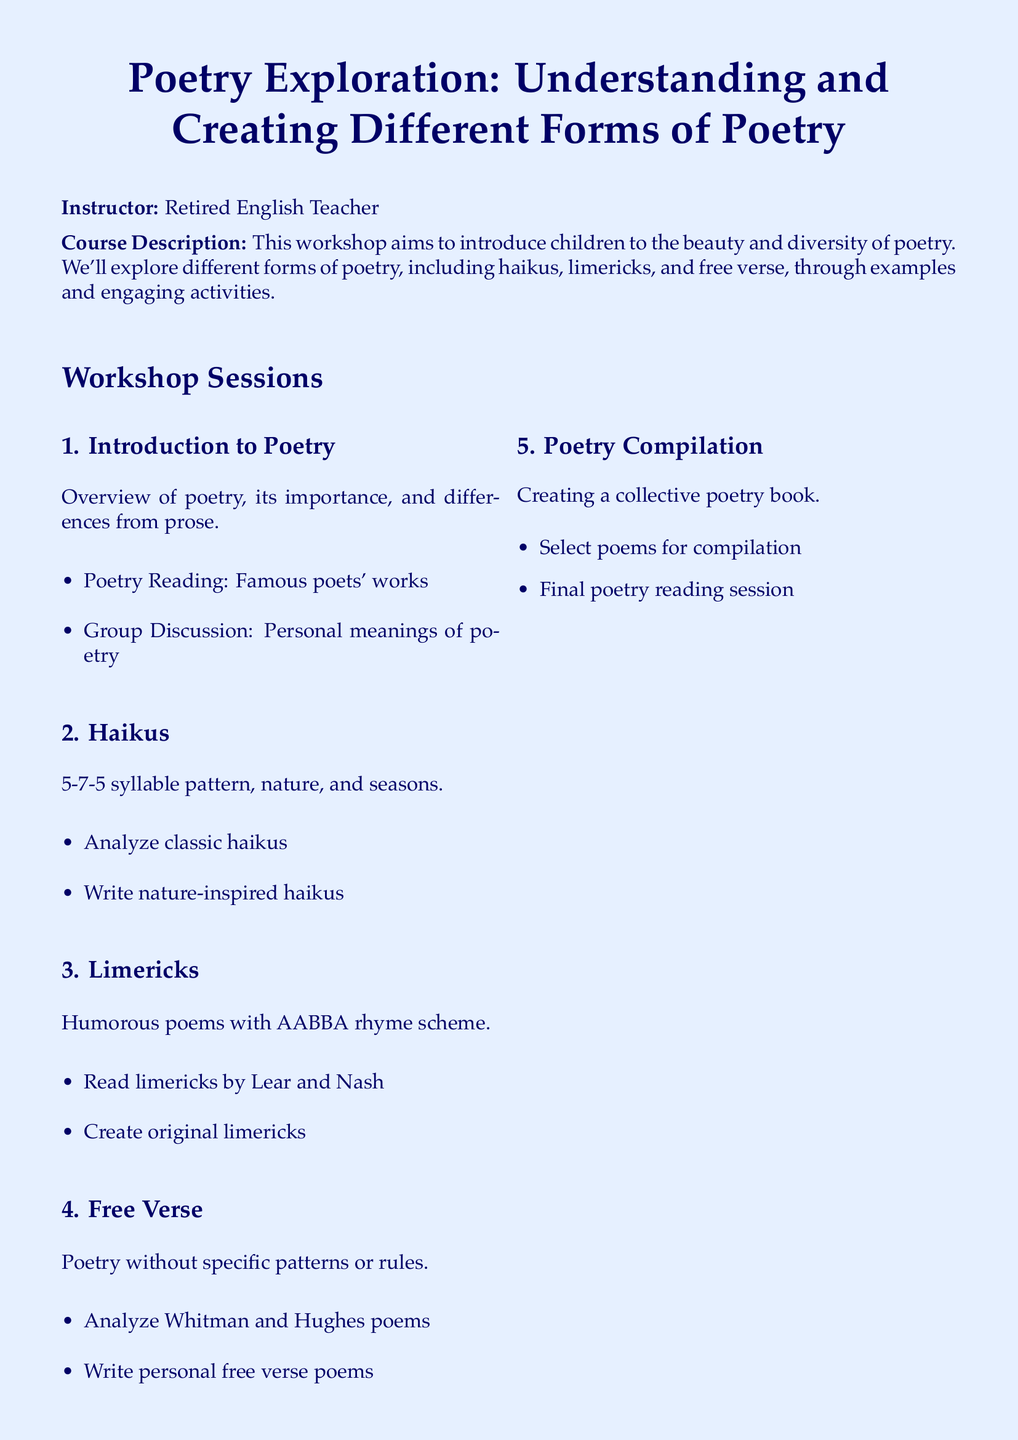What is the course title? The course title is the primary heading of the document that outlines the topic of the workshop.
Answer: Poetry Exploration: Understanding and Creating Different Forms of Poetry Who is the instructor? The instructor's name is listed in the course information section of the document.
Answer: Retired English Teacher What forms of poetry are covered in the workshop? The document lists specific types of poetry that will be explored during the sessions.
Answer: Haikus, limericks, and free verse What is the syllable pattern for haikus? The syllable pattern is mentioned in the haiku section of the workshop sessions.
Answer: 5-7-5 What is the rhyme scheme of limericks? The rhyme scheme of limericks is specifically noted in the section discussing limericks.
Answer: AABBA What is one of the materials needed for the workshop? The materials needed are listed under the section regarding workshop requirements.
Answer: Notebook and pen How many workshop sessions are listed in the syllabus? The total number of sessions can be counted from the sections outlined in the document.
Answer: Five What activity is included in the Poetry Compilation session? This refers to a specific task mentioned in the final session of the workshop.
Answer: Final poetry reading session What poetic technique does free verse employ? The document describes the nature of free verse in its corresponding section.
Answer: No specific patterns or rules 